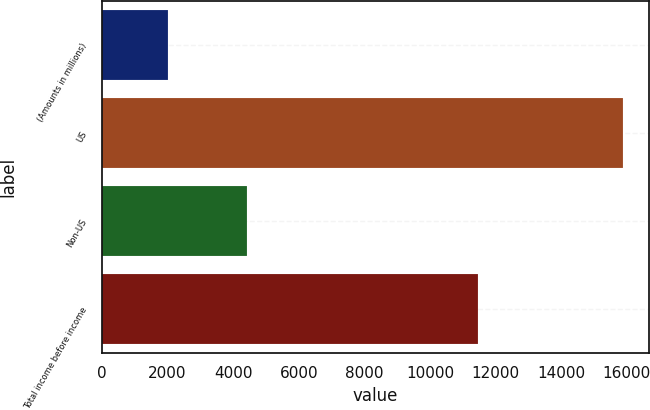Convert chart to OTSL. <chart><loc_0><loc_0><loc_500><loc_500><bar_chart><fcel>(Amounts in millions)<fcel>US<fcel>Non-US<fcel>Total income before income<nl><fcel>2019<fcel>15875<fcel>4415<fcel>11460<nl></chart> 